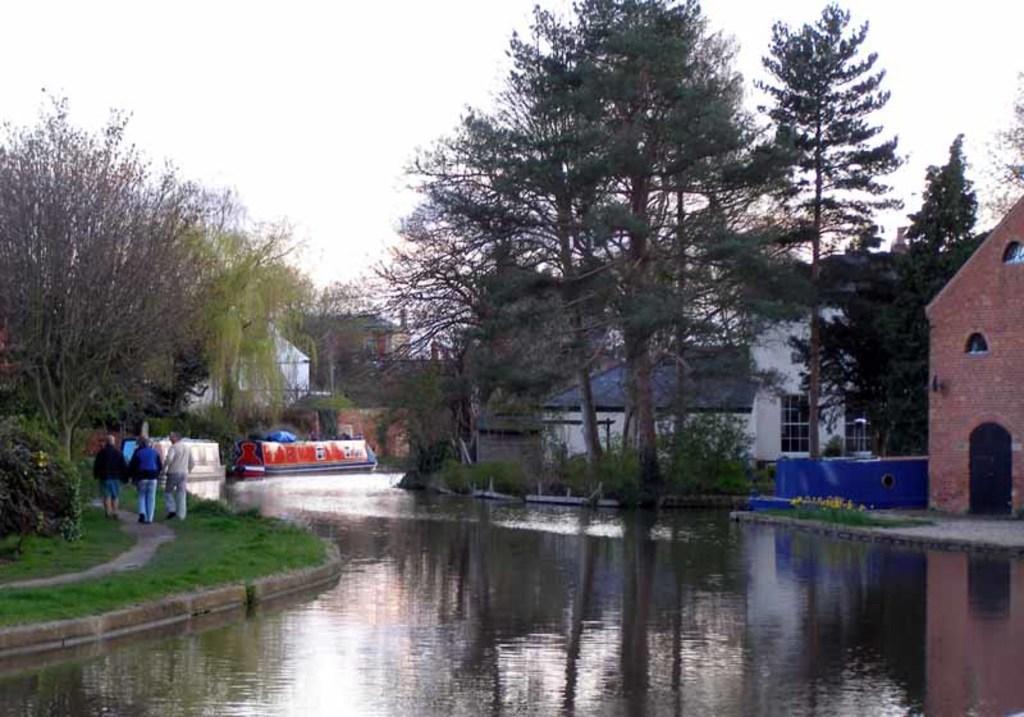How would you summarize this image in a sentence or two? In this image I can see the water. On the left side I can see three people. In the background, I can see the trees, buildings and the sky. 